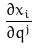<formula> <loc_0><loc_0><loc_500><loc_500>\frac { \partial x _ { i } } { \partial q ^ { j } }</formula> 